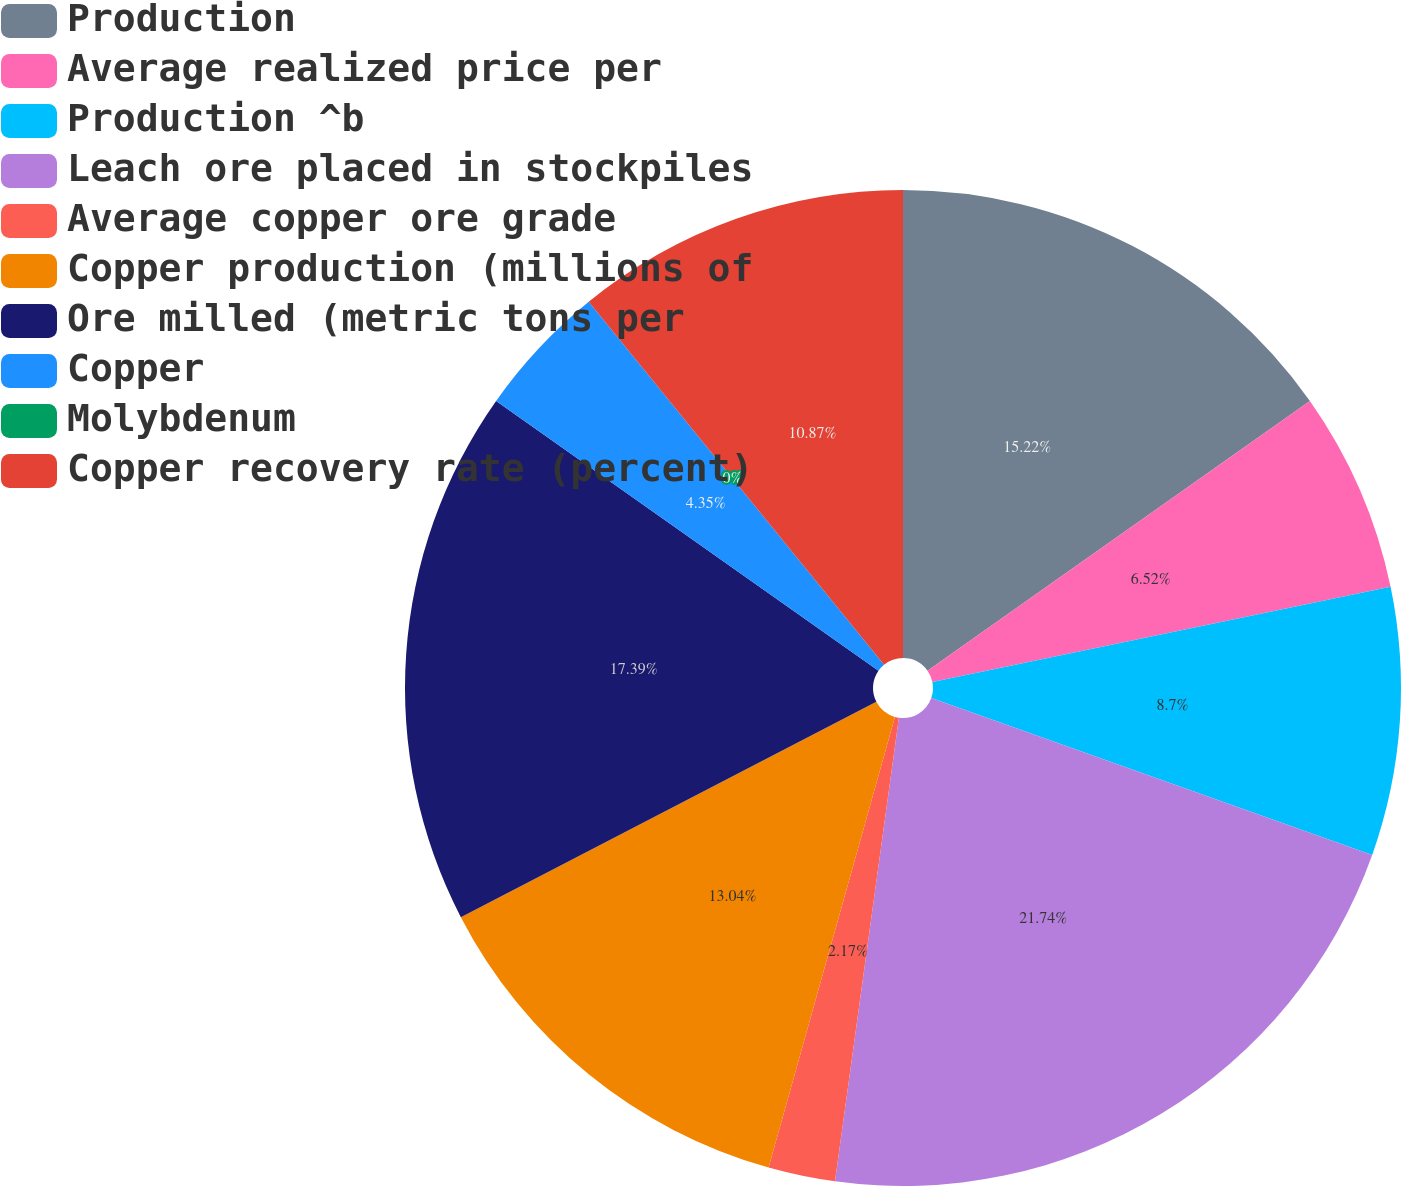Convert chart to OTSL. <chart><loc_0><loc_0><loc_500><loc_500><pie_chart><fcel>Production<fcel>Average realized price per<fcel>Production ^b<fcel>Leach ore placed in stockpiles<fcel>Average copper ore grade<fcel>Copper production (millions of<fcel>Ore milled (metric tons per<fcel>Copper<fcel>Molybdenum<fcel>Copper recovery rate (percent)<nl><fcel>15.22%<fcel>6.52%<fcel>8.7%<fcel>21.74%<fcel>2.17%<fcel>13.04%<fcel>17.39%<fcel>4.35%<fcel>0.0%<fcel>10.87%<nl></chart> 